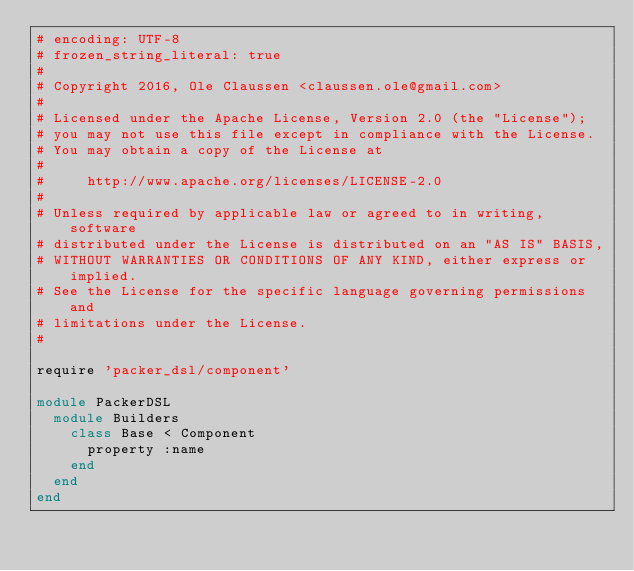Convert code to text. <code><loc_0><loc_0><loc_500><loc_500><_Ruby_># encoding: UTF-8
# frozen_string_literal: true
#
# Copyright 2016, Ole Claussen <claussen.ole@gmail.com>
#
# Licensed under the Apache License, Version 2.0 (the "License");
# you may not use this file except in compliance with the License.
# You may obtain a copy of the License at
#
#     http://www.apache.org/licenses/LICENSE-2.0
#
# Unless required by applicable law or agreed to in writing, software
# distributed under the License is distributed on an "AS IS" BASIS,
# WITHOUT WARRANTIES OR CONDITIONS OF ANY KIND, either express or implied.
# See the License for the specific language governing permissions and
# limitations under the License.
#

require 'packer_dsl/component'

module PackerDSL
  module Builders
    class Base < Component
      property :name
    end
  end
end
</code> 